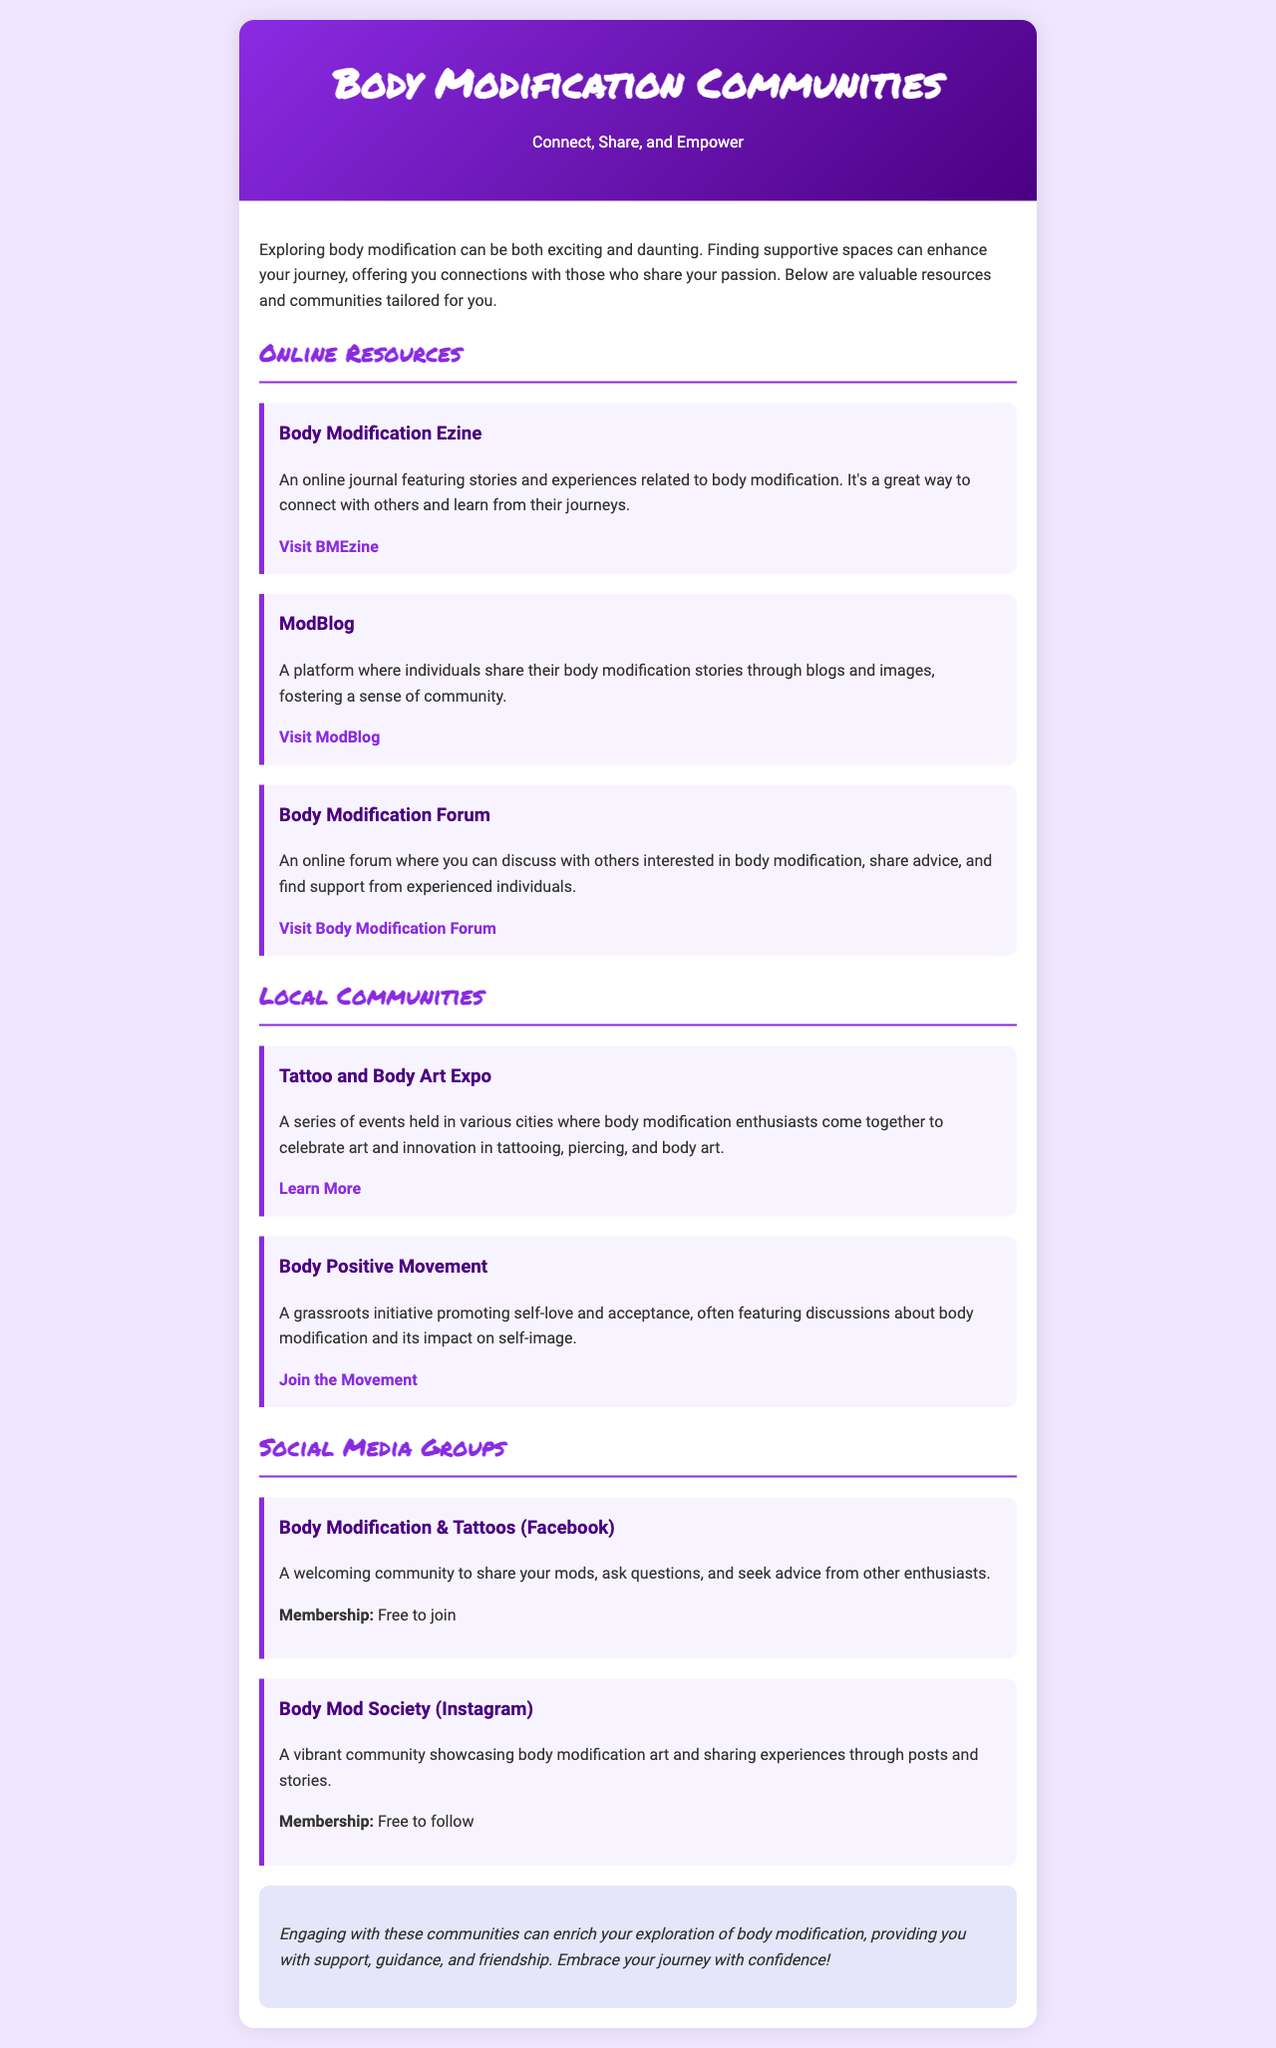what is the title of the document? The title of the document is prominently displayed in the header section.
Answer: Body Modification Communities how many online resources are listed? The document provides a count of the online resources included under the online resources section.
Answer: 3 what is one of the local communities mentioned? The local communities are specified in their own section, and one example is given.
Answer: Tattoo and Body Art Expo what type of membership is required for the Body Modification & Tattoos group? The document states the membership type required for this social media group.
Answer: Free to join what is the theme of the Body Positive Movement? The document describes the focus or initiative associated with this community.
Answer: Self-love and acceptance which website features body modification stories through blogs? The document names the platform that includes personal stories shared via blogs.
Answer: ModBlog how many social media groups are listed? The document states the total number of social media groups provided in that section.
Answer: 2 what is the color of the header background? The document describes the color scheme used in the header background.
Answer: Gradient of purple colors what is the conclusion encouraging individuals to do? The conclusion provides a type of action that it encourages individuals to embrace.
Answer: Embrace your journey with confidence! 